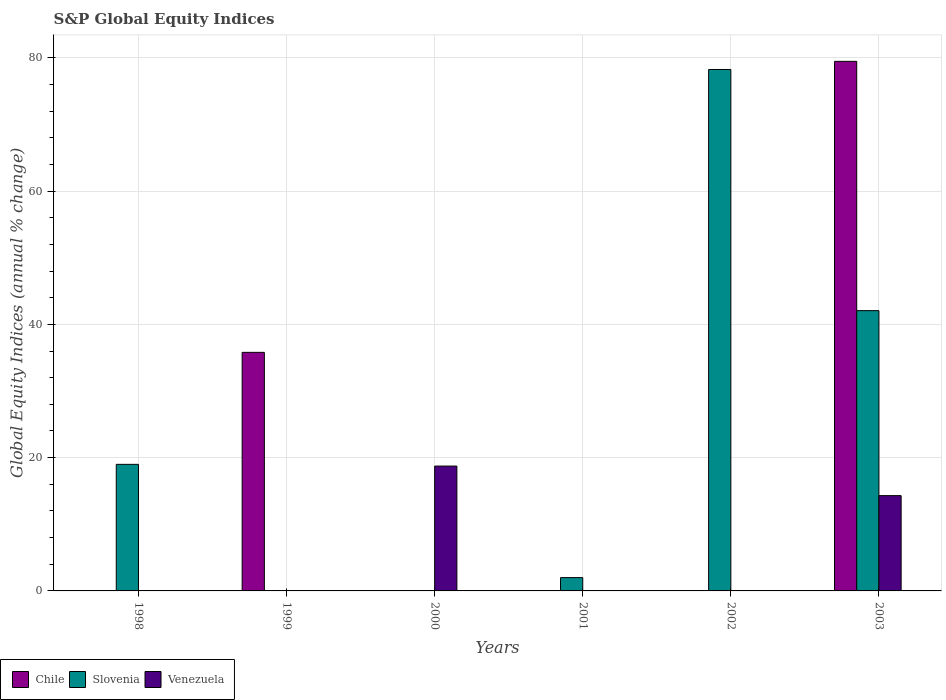How many different coloured bars are there?
Your response must be concise. 3. Are the number of bars per tick equal to the number of legend labels?
Provide a short and direct response. No. Are the number of bars on each tick of the X-axis equal?
Make the answer very short. No. In how many cases, is the number of bars for a given year not equal to the number of legend labels?
Provide a short and direct response. 5. What is the global equity indices in Chile in 1998?
Make the answer very short. 0. Across all years, what is the maximum global equity indices in Chile?
Your response must be concise. 79.47. What is the total global equity indices in Slovenia in the graph?
Your answer should be compact. 141.3. What is the difference between the global equity indices in Slovenia in 1998 and that in 2001?
Keep it short and to the point. 17. What is the difference between the global equity indices in Venezuela in 2003 and the global equity indices in Slovenia in 1999?
Keep it short and to the point. 14.3. What is the average global equity indices in Slovenia per year?
Provide a succinct answer. 23.55. In the year 2003, what is the difference between the global equity indices in Chile and global equity indices in Slovenia?
Offer a very short reply. 37.41. What is the ratio of the global equity indices in Slovenia in 1998 to that in 2001?
Offer a very short reply. 9.51. What is the difference between the highest and the second highest global equity indices in Slovenia?
Your answer should be very brief. 36.19. What is the difference between the highest and the lowest global equity indices in Chile?
Your answer should be compact. 79.47. In how many years, is the global equity indices in Chile greater than the average global equity indices in Chile taken over all years?
Ensure brevity in your answer.  2. Is it the case that in every year, the sum of the global equity indices in Venezuela and global equity indices in Slovenia is greater than the global equity indices in Chile?
Offer a very short reply. No. Are all the bars in the graph horizontal?
Your answer should be very brief. No. How many years are there in the graph?
Give a very brief answer. 6. What is the difference between two consecutive major ticks on the Y-axis?
Your answer should be compact. 20. Are the values on the major ticks of Y-axis written in scientific E-notation?
Your answer should be compact. No. How many legend labels are there?
Give a very brief answer. 3. How are the legend labels stacked?
Ensure brevity in your answer.  Horizontal. What is the title of the graph?
Your answer should be compact. S&P Global Equity Indices. Does "Liberia" appear as one of the legend labels in the graph?
Give a very brief answer. No. What is the label or title of the X-axis?
Offer a terse response. Years. What is the label or title of the Y-axis?
Ensure brevity in your answer.  Global Equity Indices (annual % change). What is the Global Equity Indices (annual % change) in Slovenia in 1998?
Provide a succinct answer. 18.99. What is the Global Equity Indices (annual % change) of Chile in 1999?
Make the answer very short. 35.8. What is the Global Equity Indices (annual % change) in Chile in 2000?
Keep it short and to the point. 0. What is the Global Equity Indices (annual % change) of Venezuela in 2000?
Your answer should be compact. 18.74. What is the Global Equity Indices (annual % change) of Chile in 2001?
Offer a very short reply. 0. What is the Global Equity Indices (annual % change) in Slovenia in 2001?
Provide a short and direct response. 2. What is the Global Equity Indices (annual % change) in Slovenia in 2002?
Provide a short and direct response. 78.25. What is the Global Equity Indices (annual % change) in Venezuela in 2002?
Provide a succinct answer. 0. What is the Global Equity Indices (annual % change) in Chile in 2003?
Your answer should be very brief. 79.47. What is the Global Equity Indices (annual % change) of Slovenia in 2003?
Provide a short and direct response. 42.06. What is the Global Equity Indices (annual % change) in Venezuela in 2003?
Keep it short and to the point. 14.3. Across all years, what is the maximum Global Equity Indices (annual % change) of Chile?
Ensure brevity in your answer.  79.47. Across all years, what is the maximum Global Equity Indices (annual % change) of Slovenia?
Your response must be concise. 78.25. Across all years, what is the maximum Global Equity Indices (annual % change) of Venezuela?
Provide a short and direct response. 18.74. Across all years, what is the minimum Global Equity Indices (annual % change) of Chile?
Make the answer very short. 0. Across all years, what is the minimum Global Equity Indices (annual % change) of Slovenia?
Your answer should be very brief. 0. What is the total Global Equity Indices (annual % change) of Chile in the graph?
Your answer should be compact. 115.27. What is the total Global Equity Indices (annual % change) of Slovenia in the graph?
Give a very brief answer. 141.3. What is the total Global Equity Indices (annual % change) of Venezuela in the graph?
Give a very brief answer. 33.04. What is the difference between the Global Equity Indices (annual % change) of Slovenia in 1998 and that in 2001?
Your answer should be very brief. 17. What is the difference between the Global Equity Indices (annual % change) in Slovenia in 1998 and that in 2002?
Provide a short and direct response. -59.26. What is the difference between the Global Equity Indices (annual % change) of Slovenia in 1998 and that in 2003?
Provide a short and direct response. -23.07. What is the difference between the Global Equity Indices (annual % change) of Chile in 1999 and that in 2003?
Make the answer very short. -43.67. What is the difference between the Global Equity Indices (annual % change) of Venezuela in 2000 and that in 2003?
Provide a short and direct response. 4.44. What is the difference between the Global Equity Indices (annual % change) in Slovenia in 2001 and that in 2002?
Make the answer very short. -76.25. What is the difference between the Global Equity Indices (annual % change) of Slovenia in 2001 and that in 2003?
Make the answer very short. -40.06. What is the difference between the Global Equity Indices (annual % change) in Slovenia in 2002 and that in 2003?
Your response must be concise. 36.19. What is the difference between the Global Equity Indices (annual % change) in Slovenia in 1998 and the Global Equity Indices (annual % change) in Venezuela in 2000?
Your answer should be very brief. 0.26. What is the difference between the Global Equity Indices (annual % change) in Slovenia in 1998 and the Global Equity Indices (annual % change) in Venezuela in 2003?
Ensure brevity in your answer.  4.69. What is the difference between the Global Equity Indices (annual % change) in Chile in 1999 and the Global Equity Indices (annual % change) in Venezuela in 2000?
Make the answer very short. 17.06. What is the difference between the Global Equity Indices (annual % change) of Chile in 1999 and the Global Equity Indices (annual % change) of Slovenia in 2001?
Your response must be concise. 33.8. What is the difference between the Global Equity Indices (annual % change) of Chile in 1999 and the Global Equity Indices (annual % change) of Slovenia in 2002?
Provide a succinct answer. -42.45. What is the difference between the Global Equity Indices (annual % change) of Chile in 1999 and the Global Equity Indices (annual % change) of Slovenia in 2003?
Offer a terse response. -6.26. What is the difference between the Global Equity Indices (annual % change) in Chile in 1999 and the Global Equity Indices (annual % change) in Venezuela in 2003?
Keep it short and to the point. 21.5. What is the difference between the Global Equity Indices (annual % change) of Slovenia in 2001 and the Global Equity Indices (annual % change) of Venezuela in 2003?
Your answer should be compact. -12.3. What is the difference between the Global Equity Indices (annual % change) in Slovenia in 2002 and the Global Equity Indices (annual % change) in Venezuela in 2003?
Ensure brevity in your answer.  63.95. What is the average Global Equity Indices (annual % change) in Chile per year?
Give a very brief answer. 19.21. What is the average Global Equity Indices (annual % change) of Slovenia per year?
Make the answer very short. 23.55. What is the average Global Equity Indices (annual % change) in Venezuela per year?
Your response must be concise. 5.51. In the year 2003, what is the difference between the Global Equity Indices (annual % change) in Chile and Global Equity Indices (annual % change) in Slovenia?
Your answer should be compact. 37.41. In the year 2003, what is the difference between the Global Equity Indices (annual % change) of Chile and Global Equity Indices (annual % change) of Venezuela?
Provide a succinct answer. 65.17. In the year 2003, what is the difference between the Global Equity Indices (annual % change) in Slovenia and Global Equity Indices (annual % change) in Venezuela?
Keep it short and to the point. 27.76. What is the ratio of the Global Equity Indices (annual % change) in Slovenia in 1998 to that in 2001?
Your response must be concise. 9.51. What is the ratio of the Global Equity Indices (annual % change) in Slovenia in 1998 to that in 2002?
Make the answer very short. 0.24. What is the ratio of the Global Equity Indices (annual % change) in Slovenia in 1998 to that in 2003?
Make the answer very short. 0.45. What is the ratio of the Global Equity Indices (annual % change) in Chile in 1999 to that in 2003?
Provide a succinct answer. 0.45. What is the ratio of the Global Equity Indices (annual % change) of Venezuela in 2000 to that in 2003?
Give a very brief answer. 1.31. What is the ratio of the Global Equity Indices (annual % change) in Slovenia in 2001 to that in 2002?
Offer a very short reply. 0.03. What is the ratio of the Global Equity Indices (annual % change) of Slovenia in 2001 to that in 2003?
Make the answer very short. 0.05. What is the ratio of the Global Equity Indices (annual % change) of Slovenia in 2002 to that in 2003?
Your response must be concise. 1.86. What is the difference between the highest and the second highest Global Equity Indices (annual % change) in Slovenia?
Your response must be concise. 36.19. What is the difference between the highest and the lowest Global Equity Indices (annual % change) in Chile?
Give a very brief answer. 79.47. What is the difference between the highest and the lowest Global Equity Indices (annual % change) of Slovenia?
Provide a short and direct response. 78.25. What is the difference between the highest and the lowest Global Equity Indices (annual % change) of Venezuela?
Your response must be concise. 18.74. 